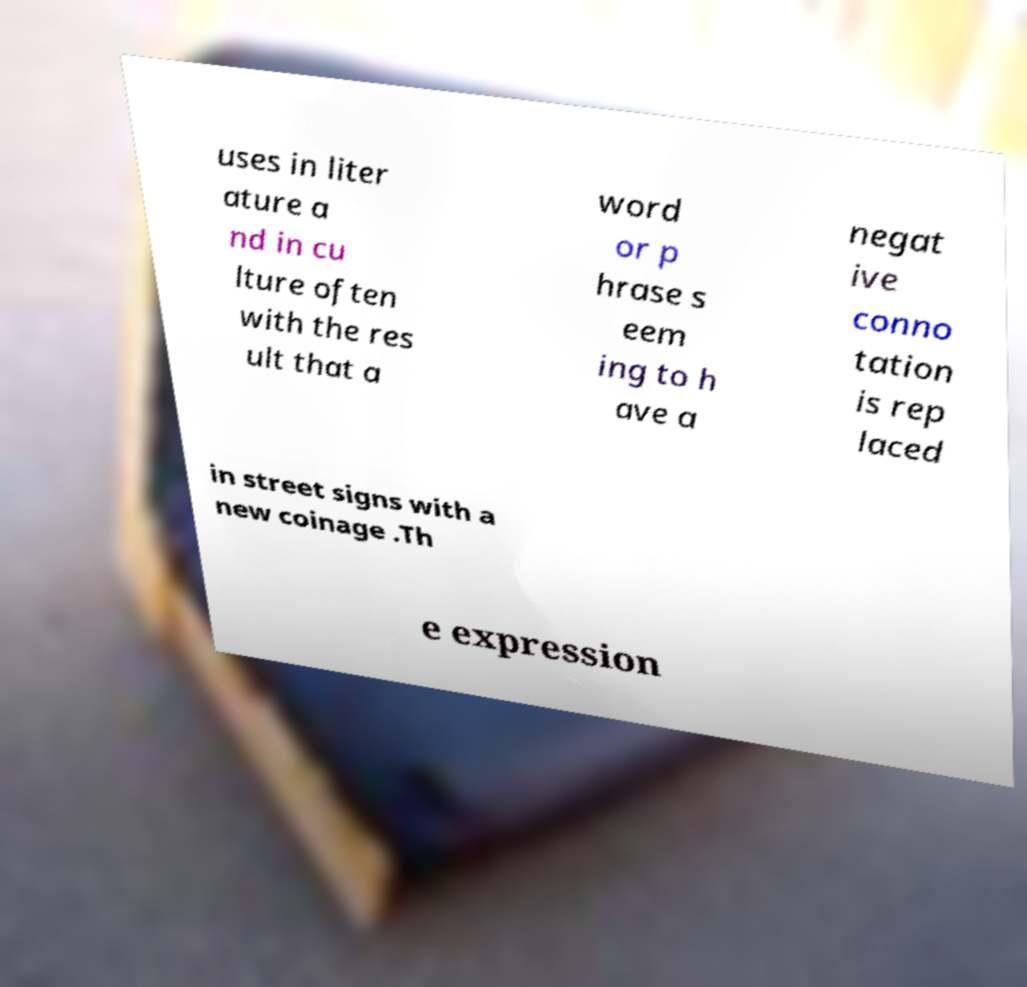Please read and relay the text visible in this image. What does it say? uses in liter ature a nd in cu lture often with the res ult that a word or p hrase s eem ing to h ave a negat ive conno tation is rep laced in street signs with a new coinage .Th e expression 